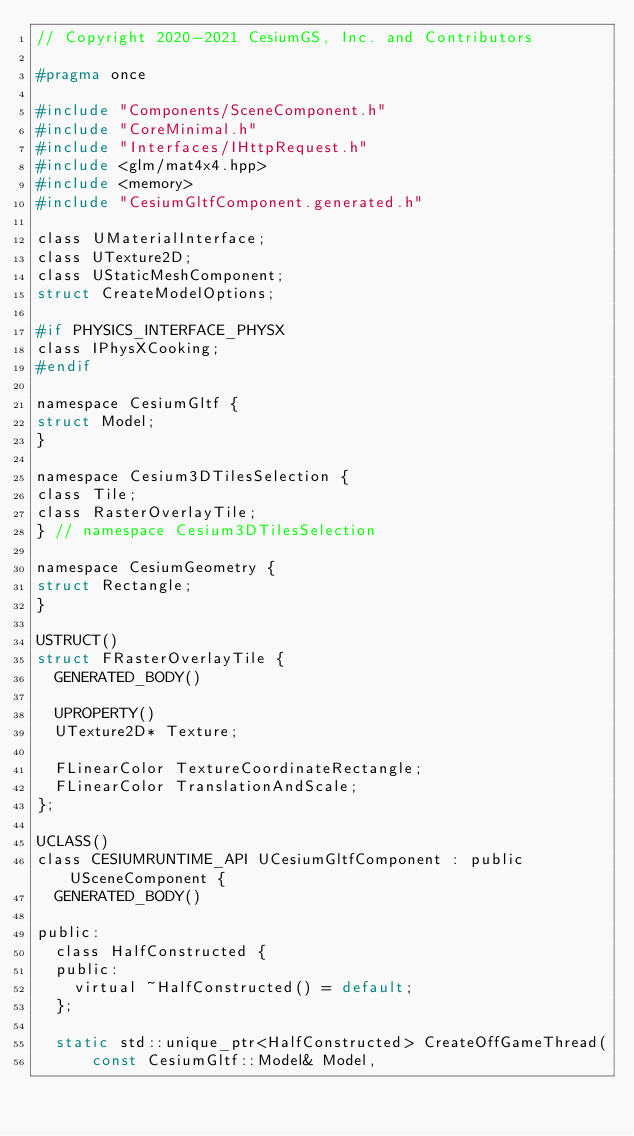Convert code to text. <code><loc_0><loc_0><loc_500><loc_500><_C_>// Copyright 2020-2021 CesiumGS, Inc. and Contributors

#pragma once

#include "Components/SceneComponent.h"
#include "CoreMinimal.h"
#include "Interfaces/IHttpRequest.h"
#include <glm/mat4x4.hpp>
#include <memory>
#include "CesiumGltfComponent.generated.h"

class UMaterialInterface;
class UTexture2D;
class UStaticMeshComponent;
struct CreateModelOptions;

#if PHYSICS_INTERFACE_PHYSX
class IPhysXCooking;
#endif

namespace CesiumGltf {
struct Model;
}

namespace Cesium3DTilesSelection {
class Tile;
class RasterOverlayTile;
} // namespace Cesium3DTilesSelection

namespace CesiumGeometry {
struct Rectangle;
}

USTRUCT()
struct FRasterOverlayTile {
  GENERATED_BODY()

  UPROPERTY()
  UTexture2D* Texture;

  FLinearColor TextureCoordinateRectangle;
  FLinearColor TranslationAndScale;
};

UCLASS()
class CESIUMRUNTIME_API UCesiumGltfComponent : public USceneComponent {
  GENERATED_BODY()

public:
  class HalfConstructed {
  public:
    virtual ~HalfConstructed() = default;
  };

  static std::unique_ptr<HalfConstructed> CreateOffGameThread(
      const CesiumGltf::Model& Model,</code> 